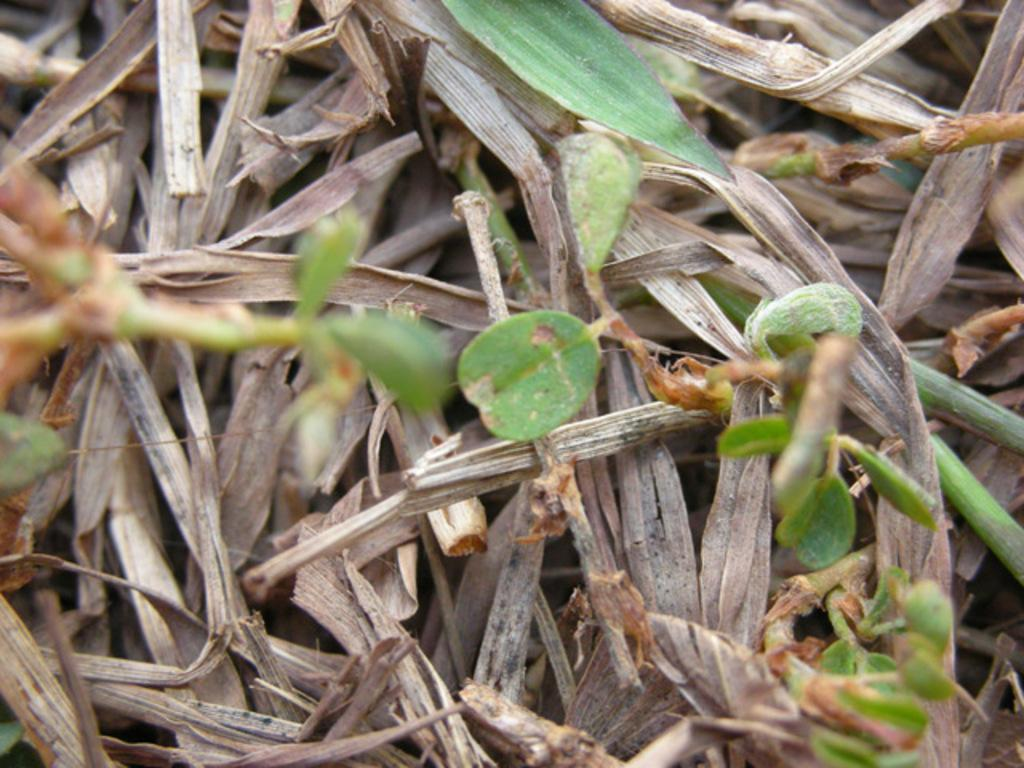What type of vegetation can be seen in the image? There are leaves and dry grass in the image. Can you describe the condition of the grass in the image? The grass in the image is dry. Where can the cobweb be found in the image? There is no cobweb present in the image. What country is depicted in the image? The image does not depict a specific country; it only shows leaves and dry grass. 